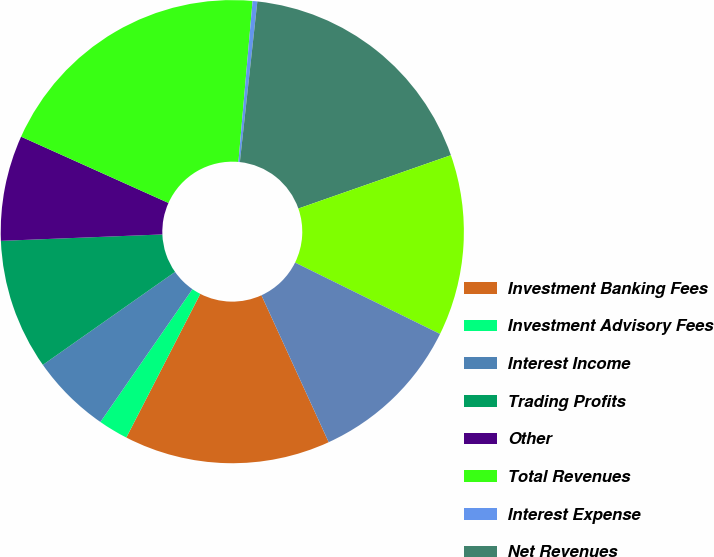<chart> <loc_0><loc_0><loc_500><loc_500><pie_chart><fcel>Investment Banking Fees<fcel>Investment Advisory Fees<fcel>Interest Income<fcel>Trading Profits<fcel>Other<fcel>Total Revenues<fcel>Interest Expense<fcel>Net Revenues<fcel>Compensation Expense<fcel>Other Expense<nl><fcel>14.4%<fcel>2.08%<fcel>5.6%<fcel>9.12%<fcel>7.36%<fcel>19.67%<fcel>0.33%<fcel>17.92%<fcel>12.64%<fcel>10.88%<nl></chart> 